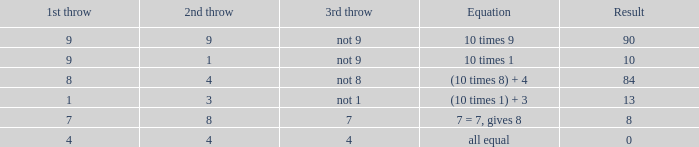What occurs when the 3rd toss isn't 8? 84.0. 